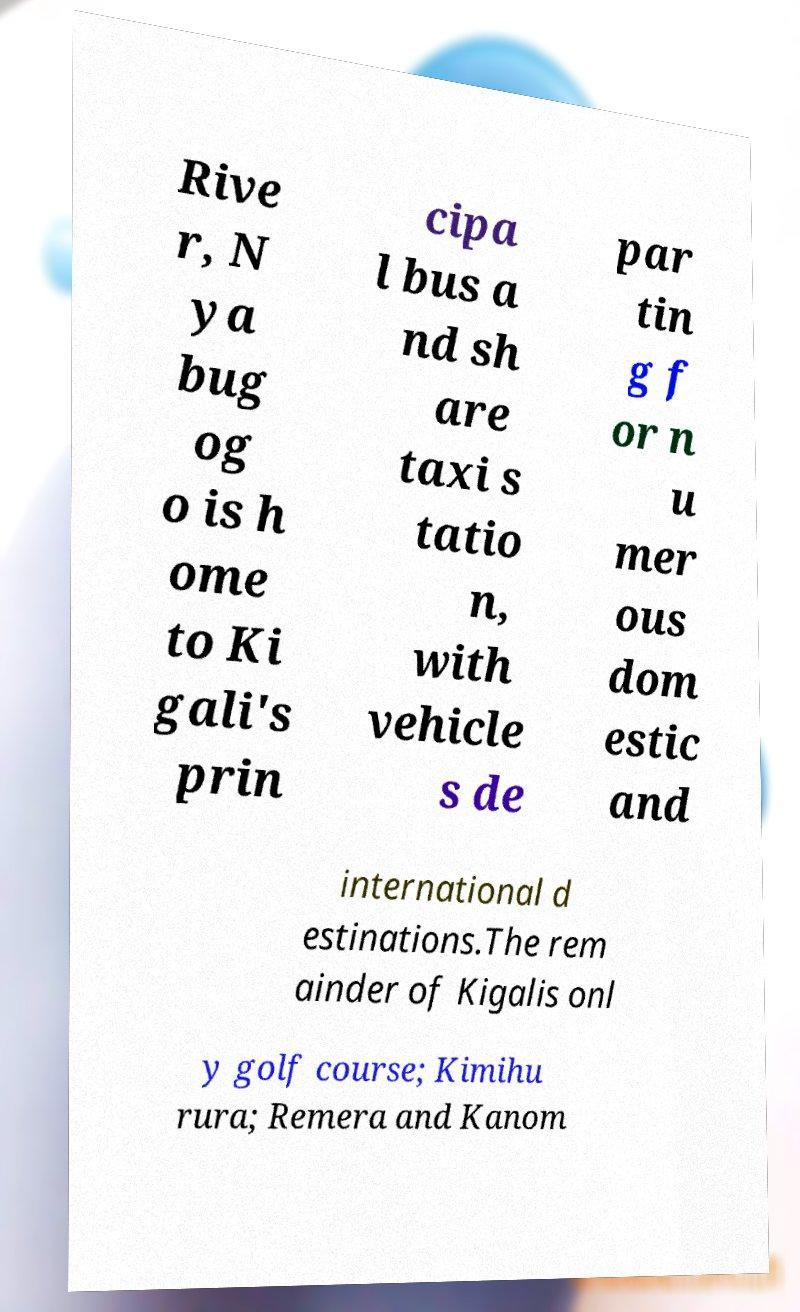What messages or text are displayed in this image? I need them in a readable, typed format. Rive r, N ya bug og o is h ome to Ki gali's prin cipa l bus a nd sh are taxi s tatio n, with vehicle s de par tin g f or n u mer ous dom estic and international d estinations.The rem ainder of Kigalis onl y golf course; Kimihu rura; Remera and Kanom 